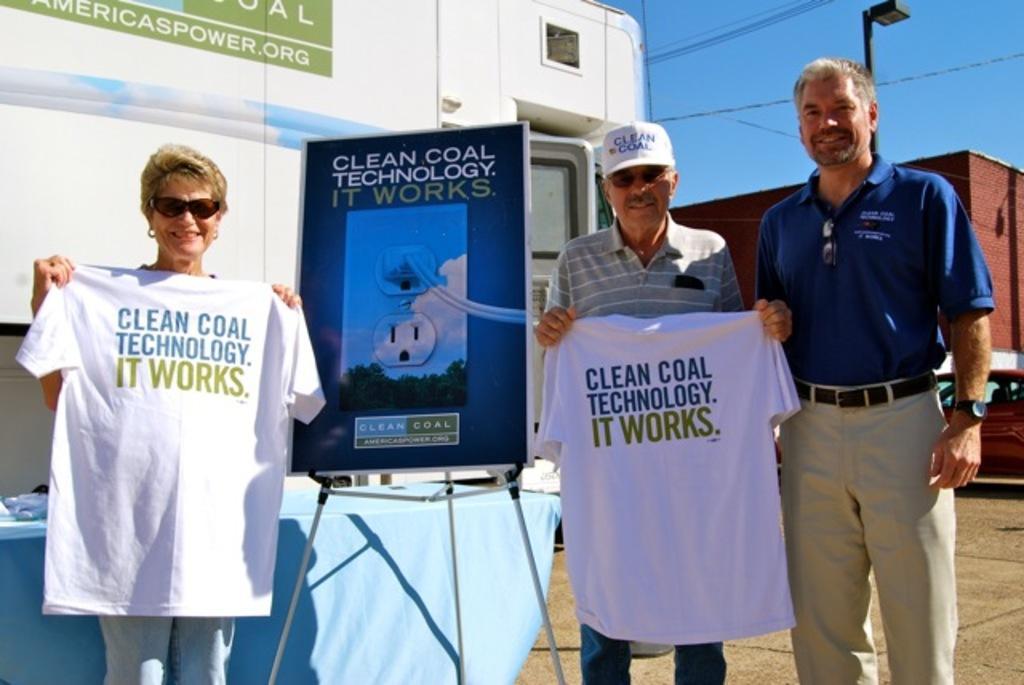Could you give a brief overview of what you see in this image? In this image there are two persons who are holding the t-shirts. In between them there is a board on the stand. On the right side there is another person who is smiling. In the background there is a van. On the right side there is a car on the floor. In the background there is a building. Beside the building there is a pole with the light. At the top there is the sky. In the background there is a table on which there is a blue color cloth. 